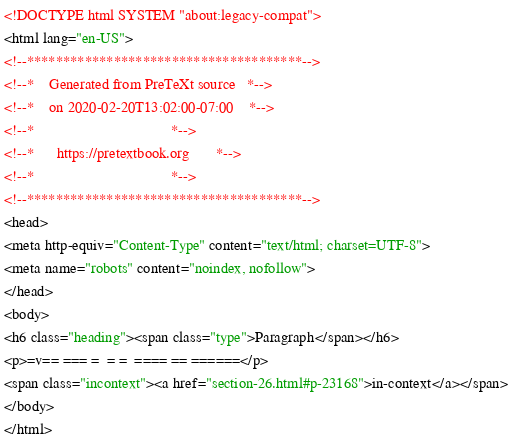Convert code to text. <code><loc_0><loc_0><loc_500><loc_500><_HTML_><!DOCTYPE html SYSTEM "about:legacy-compat">
<html lang="en-US">
<!--**************************************-->
<!--*    Generated from PreTeXt source   *-->
<!--*    on 2020-02-20T13:02:00-07:00    *-->
<!--*                                    *-->
<!--*      https://pretextbook.org       *-->
<!--*                                    *-->
<!--**************************************-->
<head>
<meta http-equiv="Content-Type" content="text/html; charset=UTF-8">
<meta name="robots" content="noindex, nofollow">
</head>
<body>
<h6 class="heading"><span class="type">Paragraph</span></h6>
<p>=v== === =  = =  ==== == ======</p>
<span class="incontext"><a href="section-26.html#p-23168">in-context</a></span>
</body>
</html>
</code> 